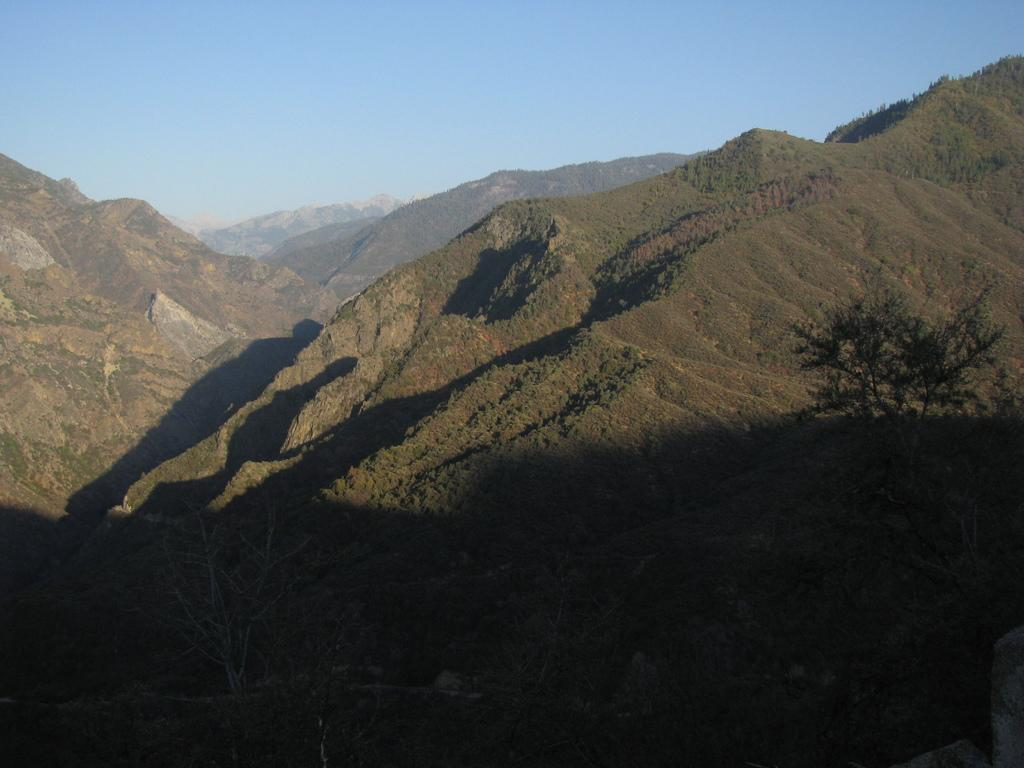What type of vegetation can be seen in the image? There are trees in the image. What geographical features are present in the image? There are hills in the image. What color is the sky in the background of the image? The blue sky is visible in the background of the image. Can you describe the stranger's tongue in the image? There is no stranger or tongue present in the image. How long does it take for the minute hand to move in the image? There is no clock or time-related element present in the image. 